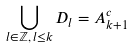<formula> <loc_0><loc_0><loc_500><loc_500>\bigcup _ { l \in \mathbb { Z } , \, l \leq k } D _ { l } = A ^ { c } _ { k + 1 }</formula> 